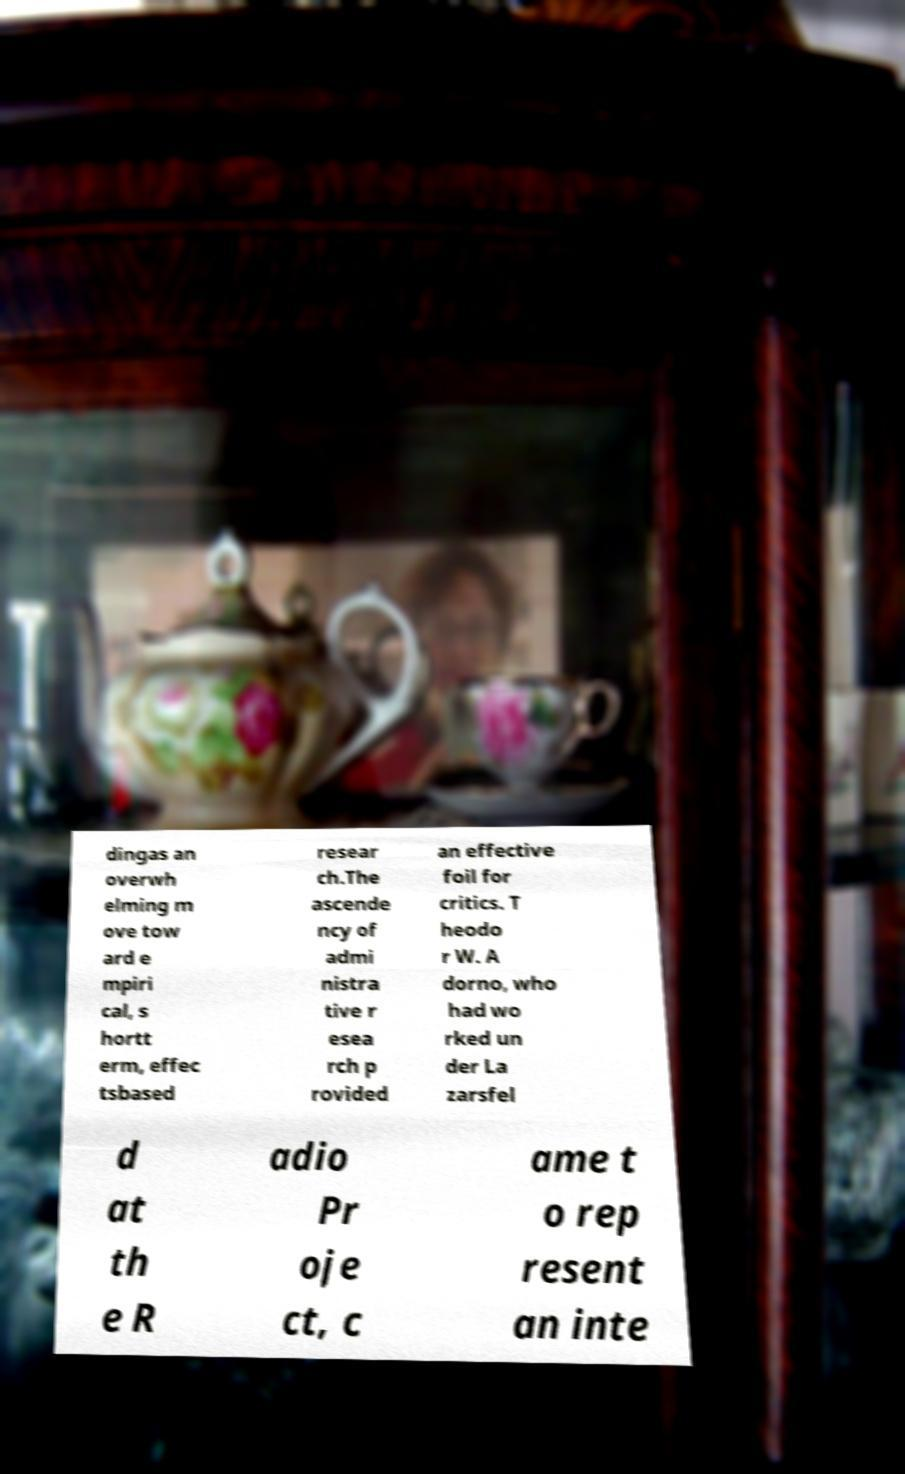What messages or text are displayed in this image? I need them in a readable, typed format. dingas an overwh elming m ove tow ard e mpiri cal, s hortt erm, effec tsbased resear ch.The ascende ncy of admi nistra tive r esea rch p rovided an effective foil for critics. T heodo r W. A dorno, who had wo rked un der La zarsfel d at th e R adio Pr oje ct, c ame t o rep resent an inte 